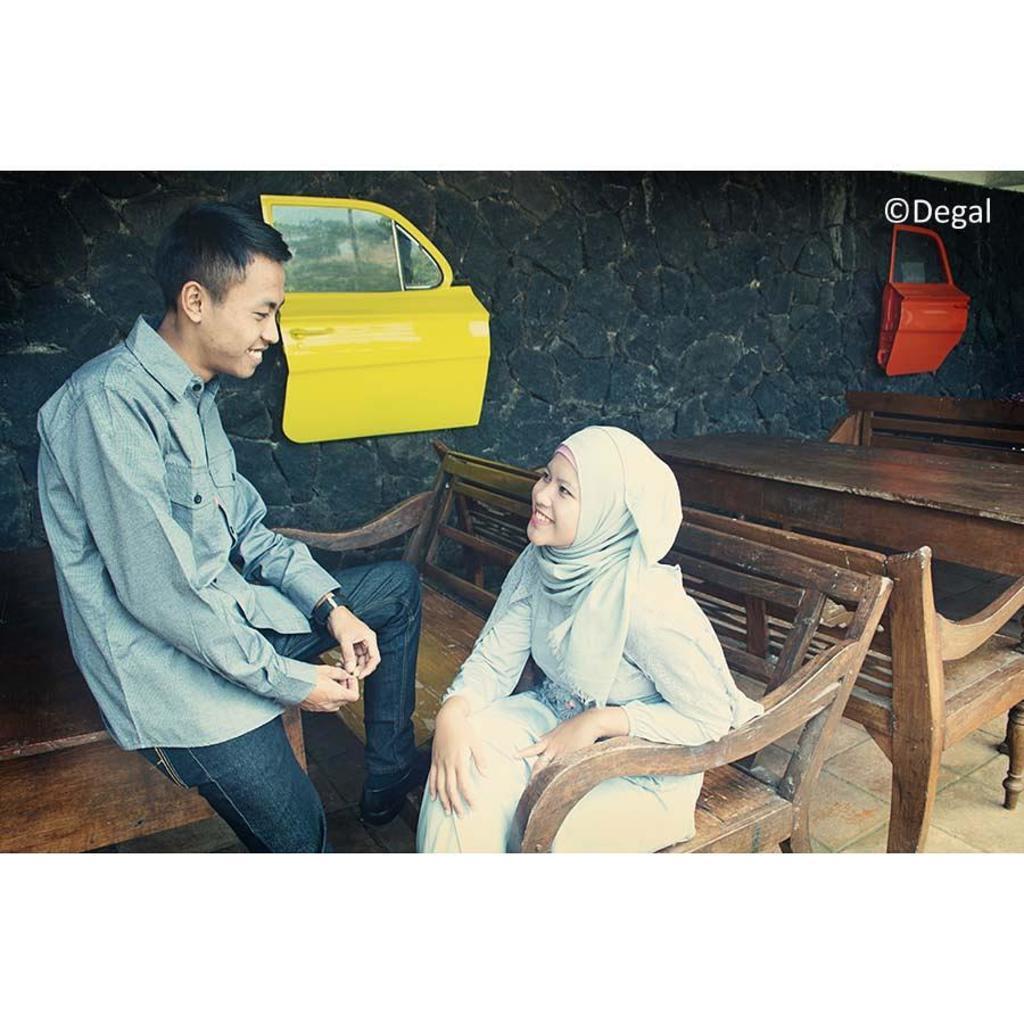Describe this image in one or two sentences. In this picture I can see a man sitting on the table, woman sitting on the bench and talking , side we can see some tables, benches, we can see some vehicle doors to the wall. 